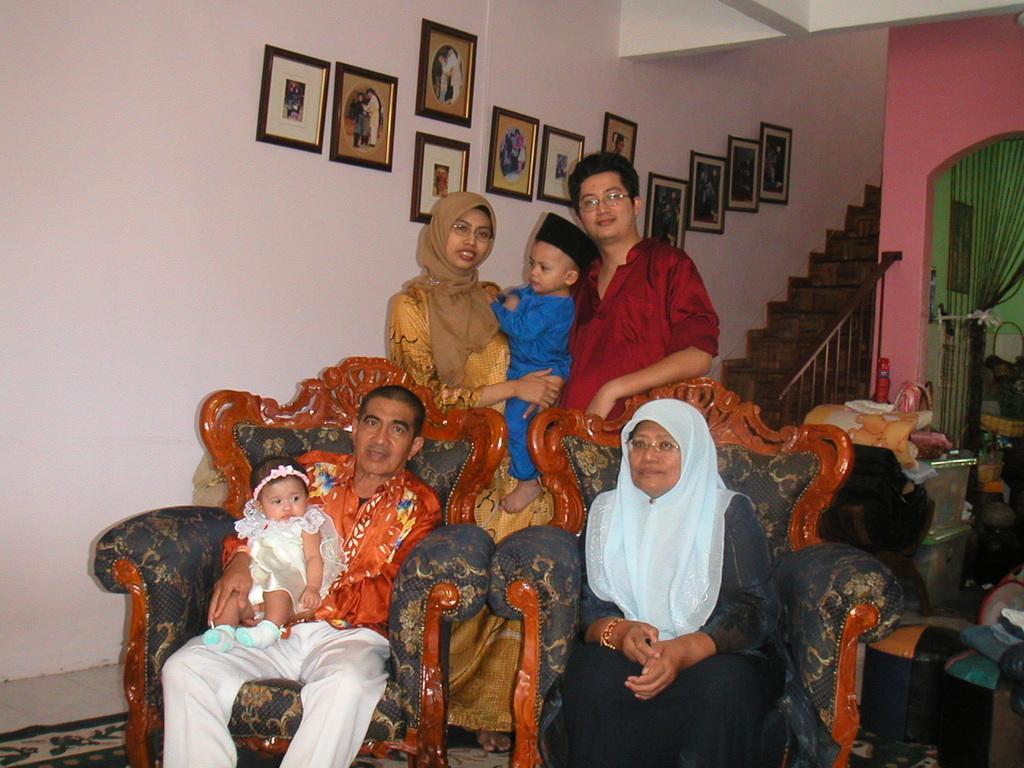In one or two sentences, can you explain what this image depicts? In this image we can see people sitting and some of them are standing. We can see stairs. There are frames placed on the wall. There are some objects and we can see a curtain. At the bottom there is a carpet and we can see a cloth. 